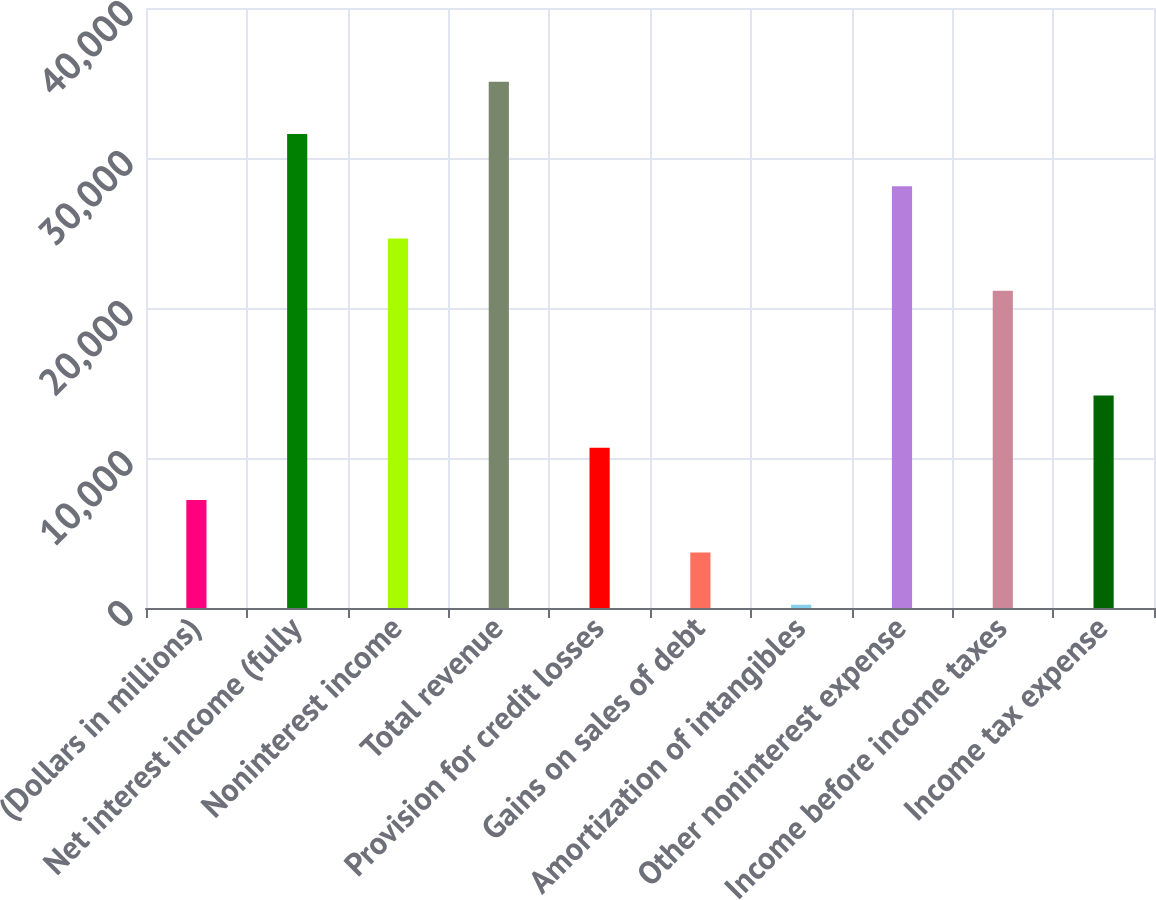Convert chart. <chart><loc_0><loc_0><loc_500><loc_500><bar_chart><fcel>(Dollars in millions)<fcel>Net interest income (fully<fcel>Noninterest income<fcel>Total revenue<fcel>Provision for credit losses<fcel>Gains on sales of debt<fcel>Amortization of intangibles<fcel>Other noninterest expense<fcel>Income before income taxes<fcel>Income tax expense<nl><fcel>7192.6<fcel>31603.7<fcel>24629.1<fcel>35091<fcel>10679.9<fcel>3705.3<fcel>218<fcel>28116.4<fcel>21141.8<fcel>14167.2<nl></chart> 